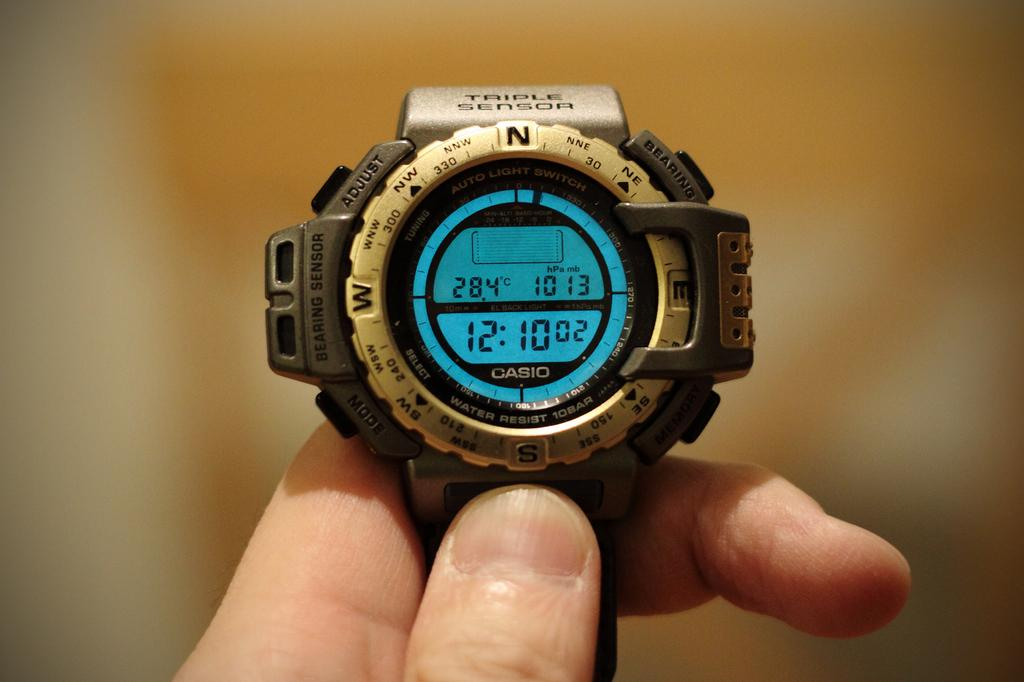<image>
Share a concise interpretation of the image provided. Triple Sensor smart watch with Bearing Sensor, Mode button, Bearing Button, and Auto Light Switch. 